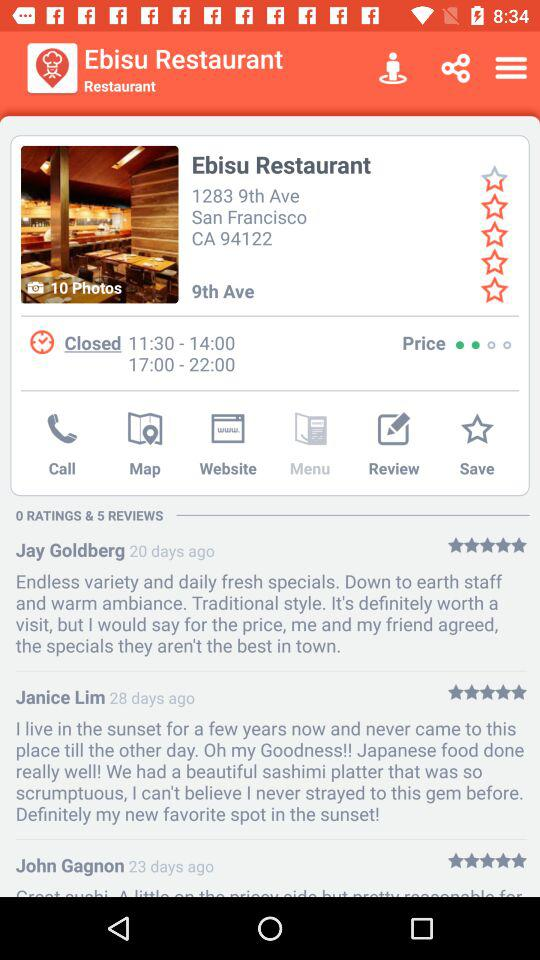When did Jay Goldberg give his review? Jay Goldberg gave his review 20 days ago. 